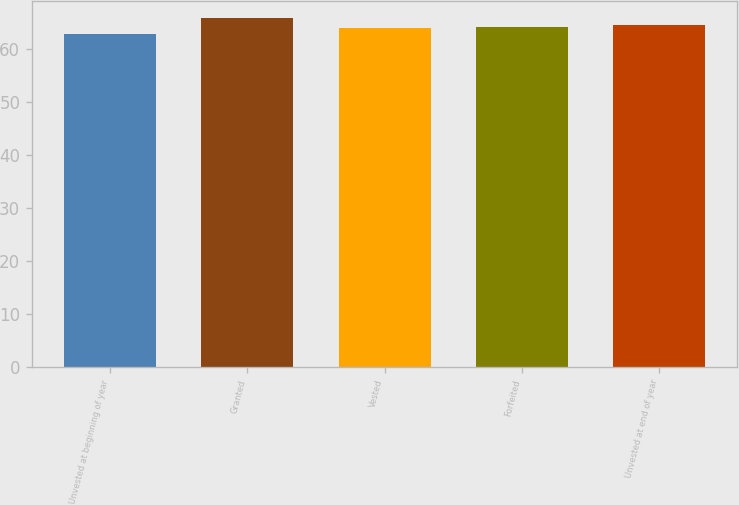<chart> <loc_0><loc_0><loc_500><loc_500><bar_chart><fcel>Unvested at beginning of year<fcel>Granted<fcel>Vested<fcel>Forfeited<fcel>Unvested at end of year<nl><fcel>62.75<fcel>65.79<fcel>63.92<fcel>64.22<fcel>64.52<nl></chart> 